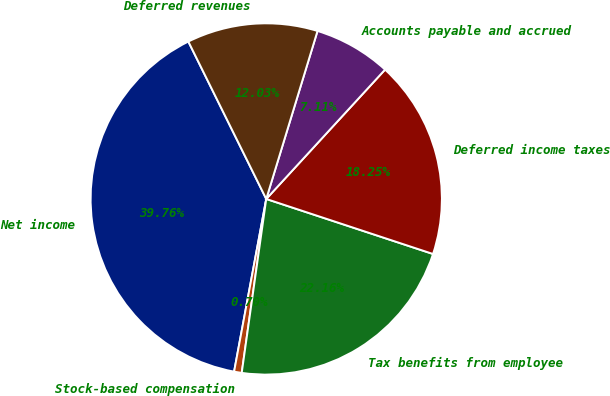<chart> <loc_0><loc_0><loc_500><loc_500><pie_chart><fcel>Net income<fcel>Stock-based compensation<fcel>Tax benefits from employee<fcel>Deferred income taxes<fcel>Accounts payable and accrued<fcel>Deferred revenues<nl><fcel>39.76%<fcel>0.7%<fcel>22.16%<fcel>18.25%<fcel>7.11%<fcel>12.03%<nl></chart> 